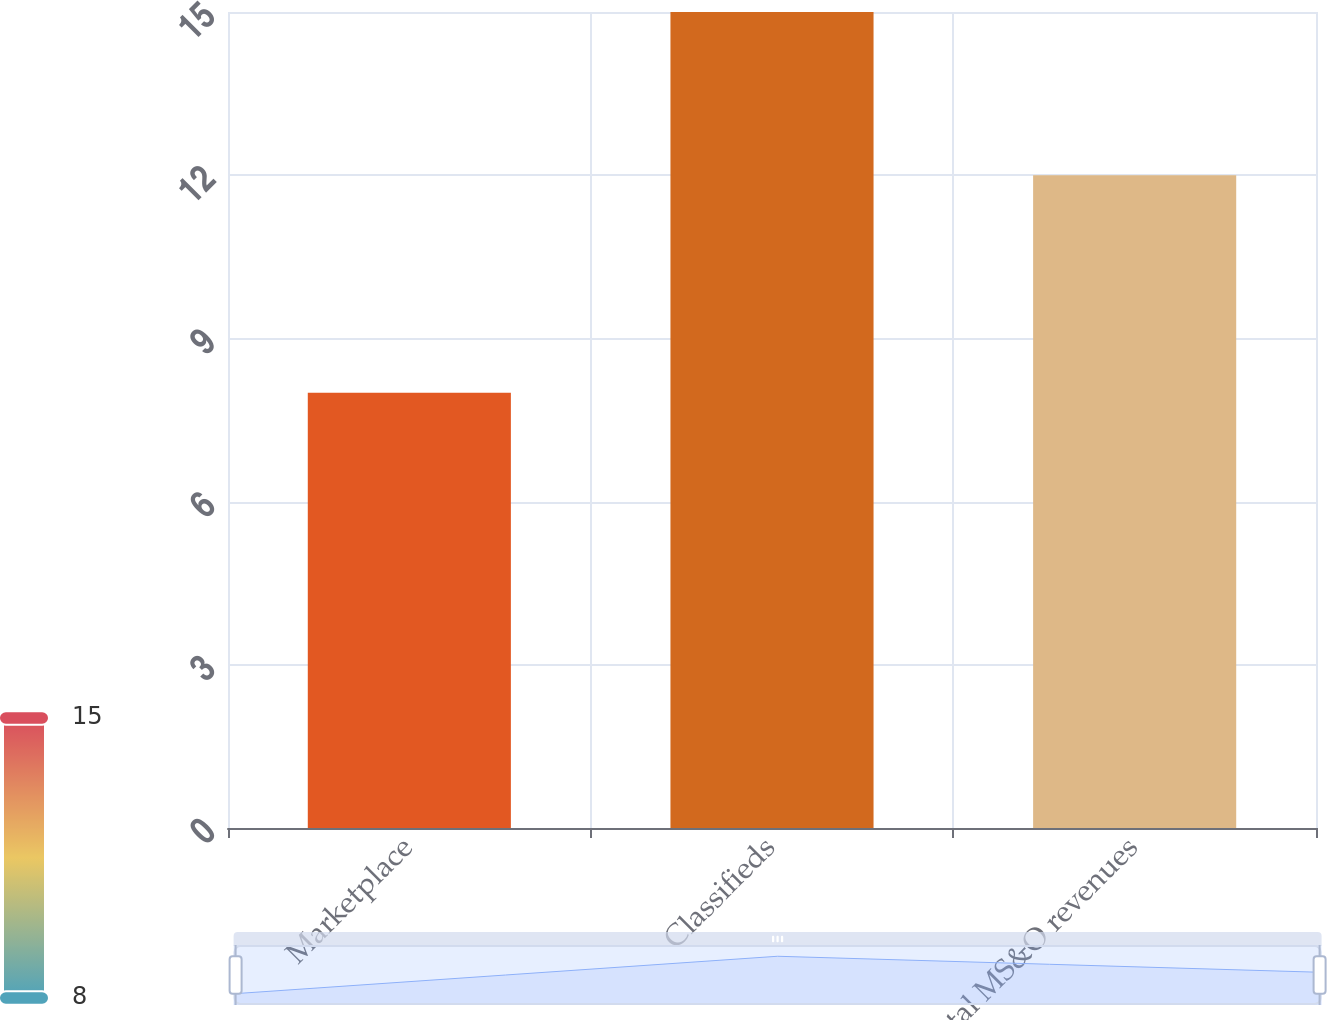Convert chart to OTSL. <chart><loc_0><loc_0><loc_500><loc_500><bar_chart><fcel>Marketplace<fcel>Classifieds<fcel>Total MS&O revenues<nl><fcel>8<fcel>15<fcel>12<nl></chart> 